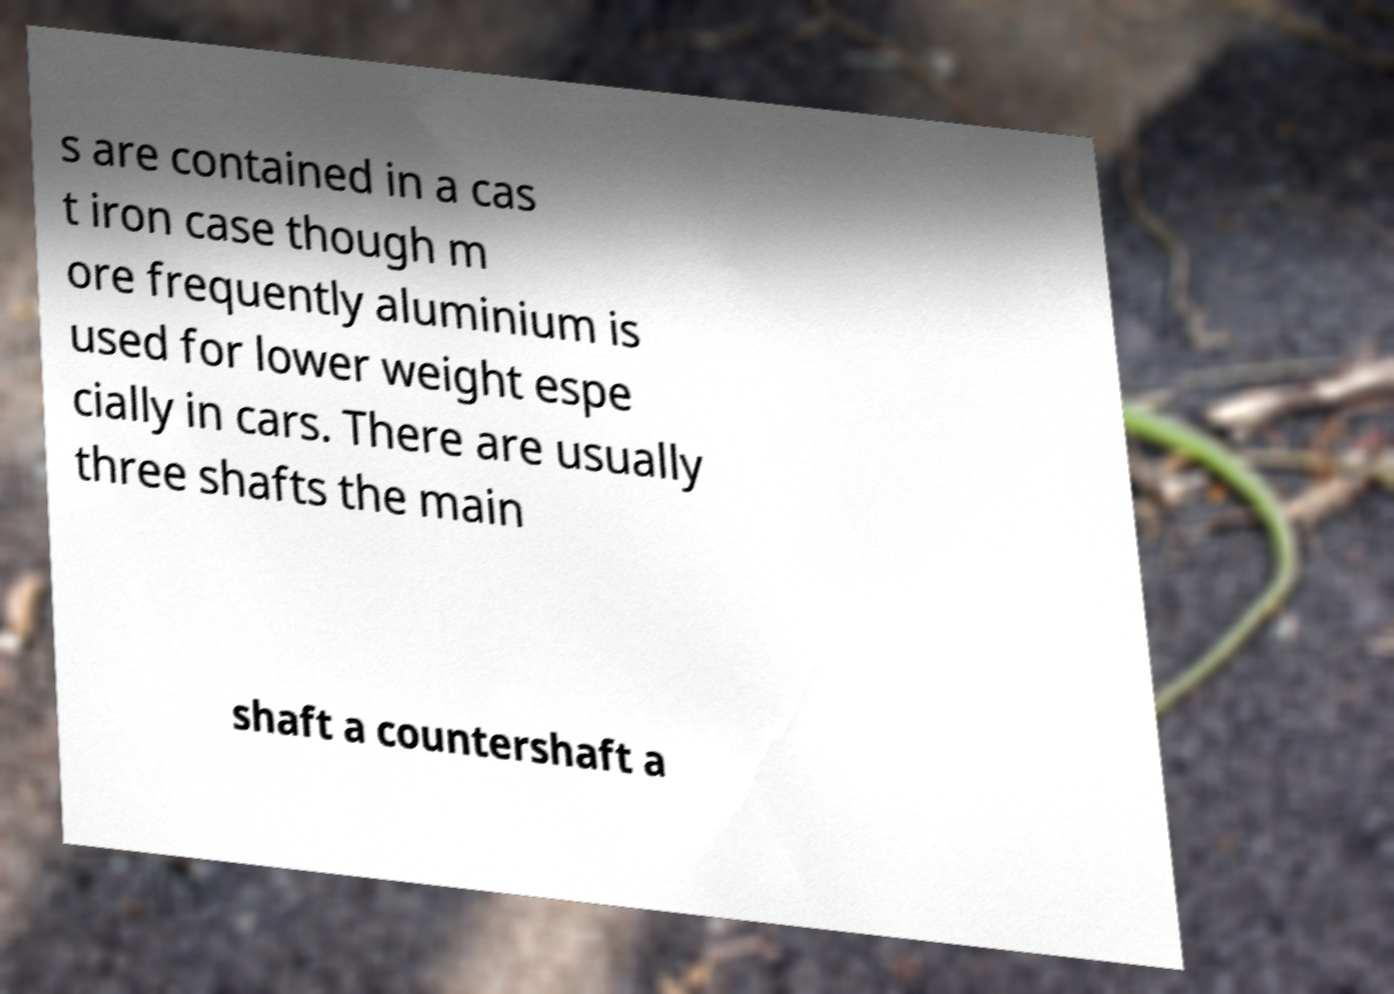I need the written content from this picture converted into text. Can you do that? s are contained in a cas t iron case though m ore frequently aluminium is used for lower weight espe cially in cars. There are usually three shafts the main shaft a countershaft a 